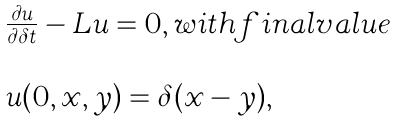<formula> <loc_0><loc_0><loc_500><loc_500>\begin{array} { l l } \frac { \partial u } { \partial \delta t } - L u = 0 , w i t h f i n a l v a l u e \\ \\ u ( 0 , x , y ) = \delta ( x - y ) , \end{array}</formula> 